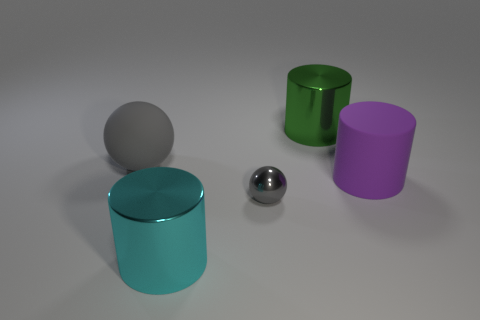Add 5 cylinders. How many objects exist? 10 Subtract all big matte cylinders. How many cylinders are left? 2 Subtract all brown spheres. Subtract all yellow cylinders. How many spheres are left? 2 Subtract all red spheres. How many green cylinders are left? 1 Subtract all small objects. Subtract all large purple matte things. How many objects are left? 3 Add 2 purple rubber cylinders. How many purple rubber cylinders are left? 3 Add 2 large cylinders. How many large cylinders exist? 5 Subtract 1 green cylinders. How many objects are left? 4 Subtract all cylinders. How many objects are left? 2 Subtract 1 balls. How many balls are left? 1 